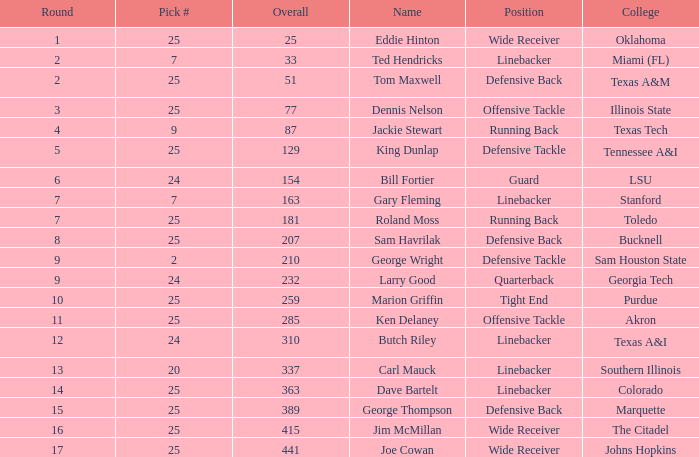Identify # of 25, and a combined of 207 has what title? Sam Havrilak. 